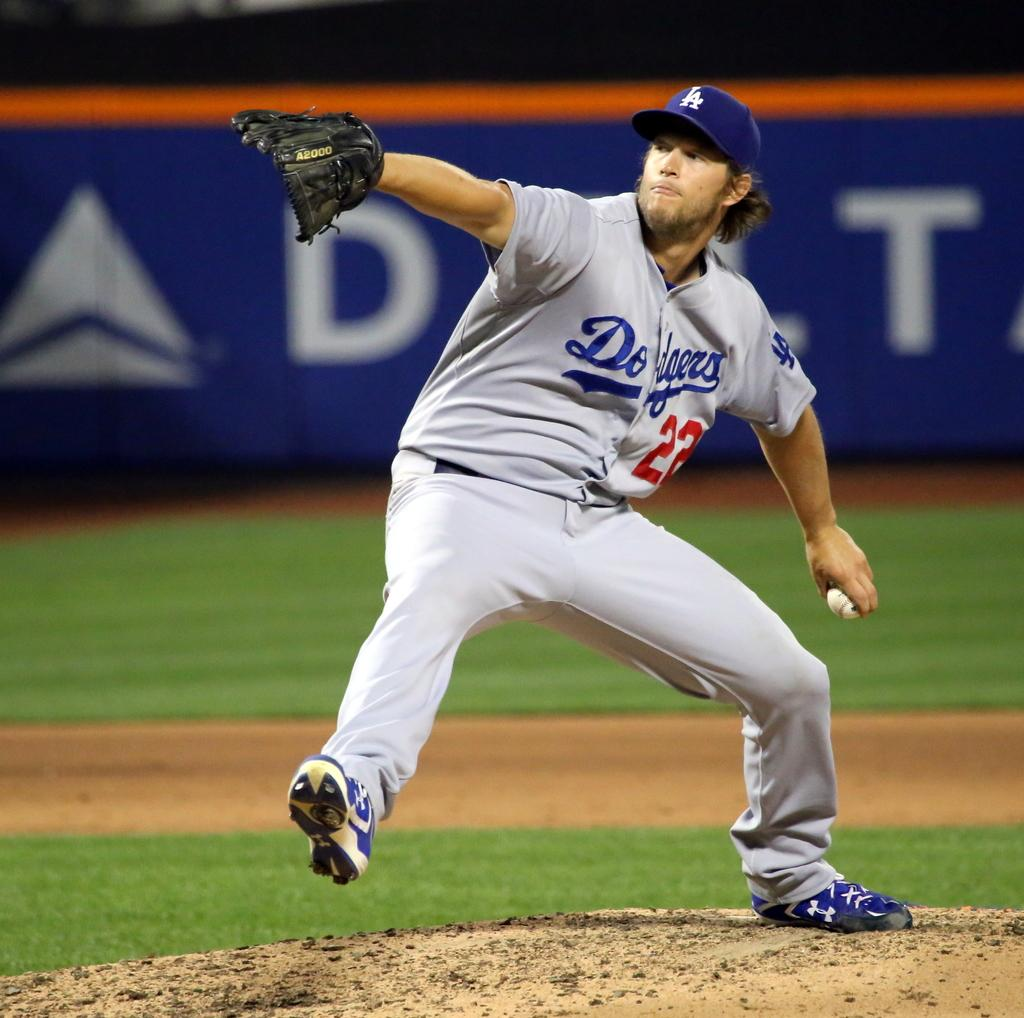<image>
Relay a brief, clear account of the picture shown. The player about to throw the ball is wearing number 22. 